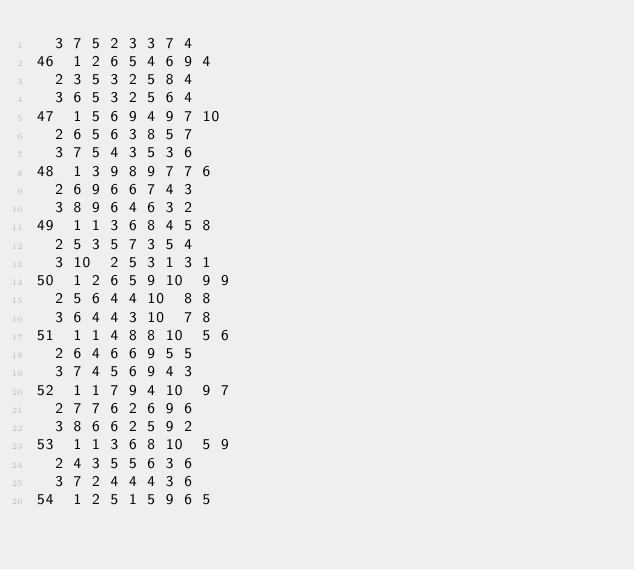Convert code to text. <code><loc_0><loc_0><loc_500><loc_500><_ObjectiveC_>	3	7	5	2	3	3	7	4	
46	1	2	6	5	4	6	9	4	
	2	3	5	3	2	5	8	4	
	3	6	5	3	2	5	6	4	
47	1	5	6	9	4	9	7	10	
	2	6	5	6	3	8	5	7	
	3	7	5	4	3	5	3	6	
48	1	3	9	8	9	7	7	6	
	2	6	9	6	6	7	4	3	
	3	8	9	6	4	6	3	2	
49	1	1	3	6	8	4	5	8	
	2	5	3	5	7	3	5	4	
	3	10	2	5	3	1	3	1	
50	1	2	6	5	9	10	9	9	
	2	5	6	4	4	10	8	8	
	3	6	4	4	3	10	7	8	
51	1	1	4	8	8	10	5	6	
	2	6	4	6	6	9	5	5	
	3	7	4	5	6	9	4	3	
52	1	1	7	9	4	10	9	7	
	2	7	7	6	2	6	9	6	
	3	8	6	6	2	5	9	2	
53	1	1	3	6	8	10	5	9	
	2	4	3	5	5	6	3	6	
	3	7	2	4	4	4	3	6	
54	1	2	5	1	5	9	6	5	</code> 